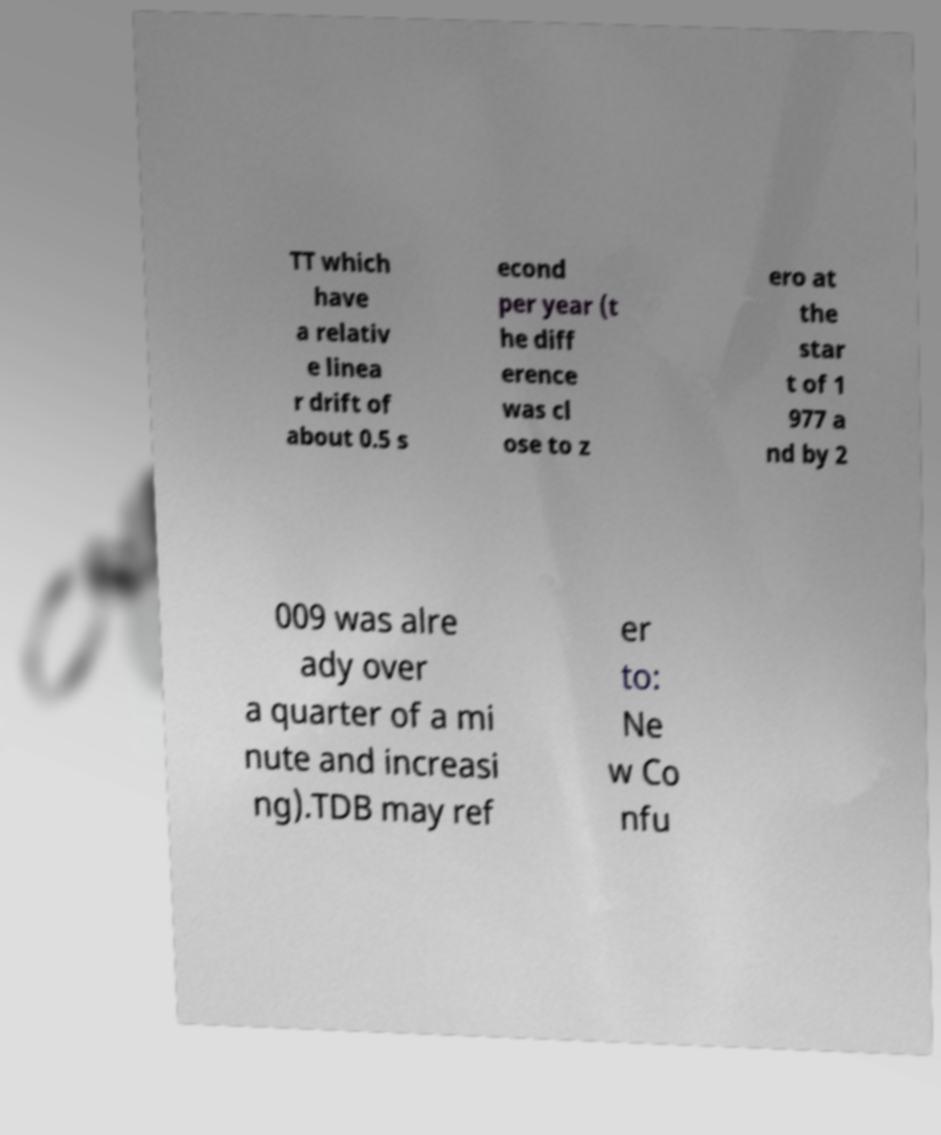I need the written content from this picture converted into text. Can you do that? TT which have a relativ e linea r drift of about 0.5 s econd per year (t he diff erence was cl ose to z ero at the star t of 1 977 a nd by 2 009 was alre ady over a quarter of a mi nute and increasi ng).TDB may ref er to: Ne w Co nfu 